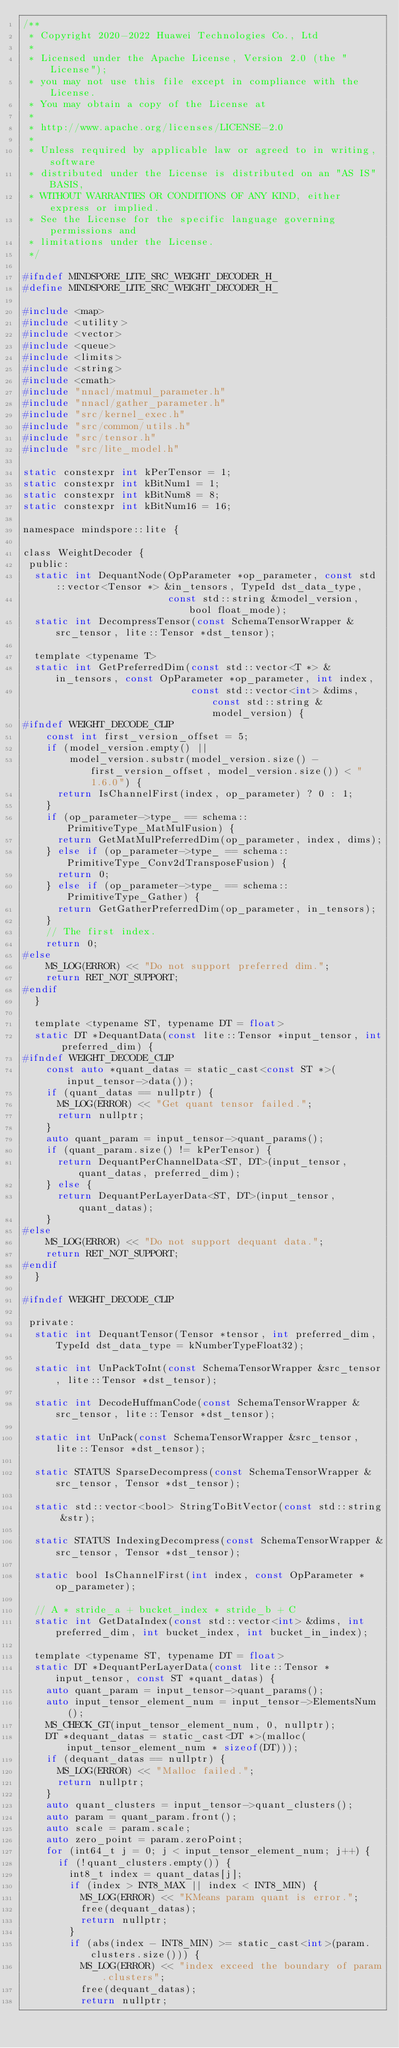<code> <loc_0><loc_0><loc_500><loc_500><_C_>/**
 * Copyright 2020-2022 Huawei Technologies Co., Ltd
 *
 * Licensed under the Apache License, Version 2.0 (the "License");
 * you may not use this file except in compliance with the License.
 * You may obtain a copy of the License at
 *
 * http://www.apache.org/licenses/LICENSE-2.0
 *
 * Unless required by applicable law or agreed to in writing, software
 * distributed under the License is distributed on an "AS IS" BASIS,
 * WITHOUT WARRANTIES OR CONDITIONS OF ANY KIND, either express or implied.
 * See the License for the specific language governing permissions and
 * limitations under the License.
 */

#ifndef MINDSPORE_LITE_SRC_WEIGHT_DECODER_H_
#define MINDSPORE_LITE_SRC_WEIGHT_DECODER_H_

#include <map>
#include <utility>
#include <vector>
#include <queue>
#include <limits>
#include <string>
#include <cmath>
#include "nnacl/matmul_parameter.h"
#include "nnacl/gather_parameter.h"
#include "src/kernel_exec.h"
#include "src/common/utils.h"
#include "src/tensor.h"
#include "src/lite_model.h"

static constexpr int kPerTensor = 1;
static constexpr int kBitNum1 = 1;
static constexpr int kBitNum8 = 8;
static constexpr int kBitNum16 = 16;

namespace mindspore::lite {

class WeightDecoder {
 public:
  static int DequantNode(OpParameter *op_parameter, const std::vector<Tensor *> &in_tensors, TypeId dst_data_type,
                         const std::string &model_version, bool float_mode);
  static int DecompressTensor(const SchemaTensorWrapper &src_tensor, lite::Tensor *dst_tensor);

  template <typename T>
  static int GetPreferredDim(const std::vector<T *> &in_tensors, const OpParameter *op_parameter, int index,
                             const std::vector<int> &dims, const std::string &model_version) {
#ifndef WEIGHT_DECODE_CLIP
    const int first_version_offset = 5;
    if (model_version.empty() ||
        model_version.substr(model_version.size() - first_version_offset, model_version.size()) < "1.6.0") {
      return IsChannelFirst(index, op_parameter) ? 0 : 1;
    }
    if (op_parameter->type_ == schema::PrimitiveType_MatMulFusion) {
      return GetMatMulPreferredDim(op_parameter, index, dims);
    } else if (op_parameter->type_ == schema::PrimitiveType_Conv2dTransposeFusion) {
      return 0;
    } else if (op_parameter->type_ == schema::PrimitiveType_Gather) {
      return GetGatherPreferredDim(op_parameter, in_tensors);
    }
    // The first index.
    return 0;
#else
    MS_LOG(ERROR) << "Do not support preferred dim.";
    return RET_NOT_SUPPORT;
#endif
  }

  template <typename ST, typename DT = float>
  static DT *DequantData(const lite::Tensor *input_tensor, int preferred_dim) {
#ifndef WEIGHT_DECODE_CLIP
    const auto *quant_datas = static_cast<const ST *>(input_tensor->data());
    if (quant_datas == nullptr) {
      MS_LOG(ERROR) << "Get quant tensor failed.";
      return nullptr;
    }
    auto quant_param = input_tensor->quant_params();
    if (quant_param.size() != kPerTensor) {
      return DequantPerChannelData<ST, DT>(input_tensor, quant_datas, preferred_dim);
    } else {
      return DequantPerLayerData<ST, DT>(input_tensor, quant_datas);
    }
#else
    MS_LOG(ERROR) << "Do not support dequant data.";
    return RET_NOT_SUPPORT;
#endif
  }

#ifndef WEIGHT_DECODE_CLIP

 private:
  static int DequantTensor(Tensor *tensor, int preferred_dim, TypeId dst_data_type = kNumberTypeFloat32);

  static int UnPackToInt(const SchemaTensorWrapper &src_tensor, lite::Tensor *dst_tensor);

  static int DecodeHuffmanCode(const SchemaTensorWrapper &src_tensor, lite::Tensor *dst_tensor);

  static int UnPack(const SchemaTensorWrapper &src_tensor, lite::Tensor *dst_tensor);

  static STATUS SparseDecompress(const SchemaTensorWrapper &src_tensor, Tensor *dst_tensor);

  static std::vector<bool> StringToBitVector(const std::string &str);

  static STATUS IndexingDecompress(const SchemaTensorWrapper &src_tensor, Tensor *dst_tensor);

  static bool IsChannelFirst(int index, const OpParameter *op_parameter);

  // A * stride_a + bucket_index * stride_b + C
  static int GetDataIndex(const std::vector<int> &dims, int preferred_dim, int bucket_index, int bucket_in_index);

  template <typename ST, typename DT = float>
  static DT *DequantPerLayerData(const lite::Tensor *input_tensor, const ST *quant_datas) {
    auto quant_param = input_tensor->quant_params();
    auto input_tensor_element_num = input_tensor->ElementsNum();
    MS_CHECK_GT(input_tensor_element_num, 0, nullptr);
    DT *dequant_datas = static_cast<DT *>(malloc(input_tensor_element_num * sizeof(DT)));
    if (dequant_datas == nullptr) {
      MS_LOG(ERROR) << "Malloc failed.";
      return nullptr;
    }
    auto quant_clusters = input_tensor->quant_clusters();
    auto param = quant_param.front();
    auto scale = param.scale;
    auto zero_point = param.zeroPoint;
    for (int64_t j = 0; j < input_tensor_element_num; j++) {
      if (!quant_clusters.empty()) {
        int8_t index = quant_datas[j];
        if (index > INT8_MAX || index < INT8_MIN) {
          MS_LOG(ERROR) << "KMeans param quant is error.";
          free(dequant_datas);
          return nullptr;
        }
        if (abs(index - INT8_MIN) >= static_cast<int>(param.clusters.size())) {
          MS_LOG(ERROR) << "index exceed the boundary of param.clusters";
          free(dequant_datas);
          return nullptr;</code> 